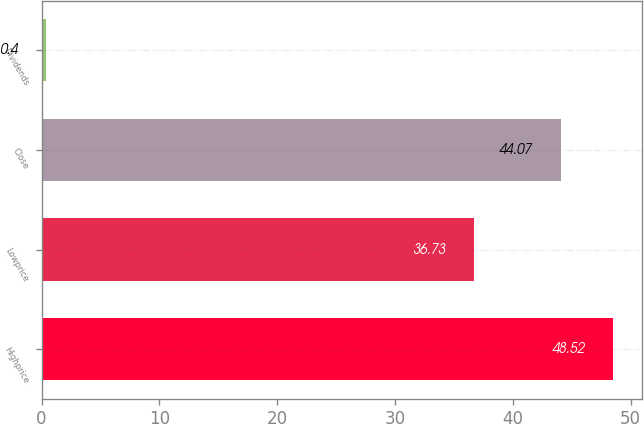<chart> <loc_0><loc_0><loc_500><loc_500><bar_chart><fcel>Highprice<fcel>Lowprice<fcel>Close<fcel>Dividends<nl><fcel>48.52<fcel>36.73<fcel>44.07<fcel>0.4<nl></chart> 